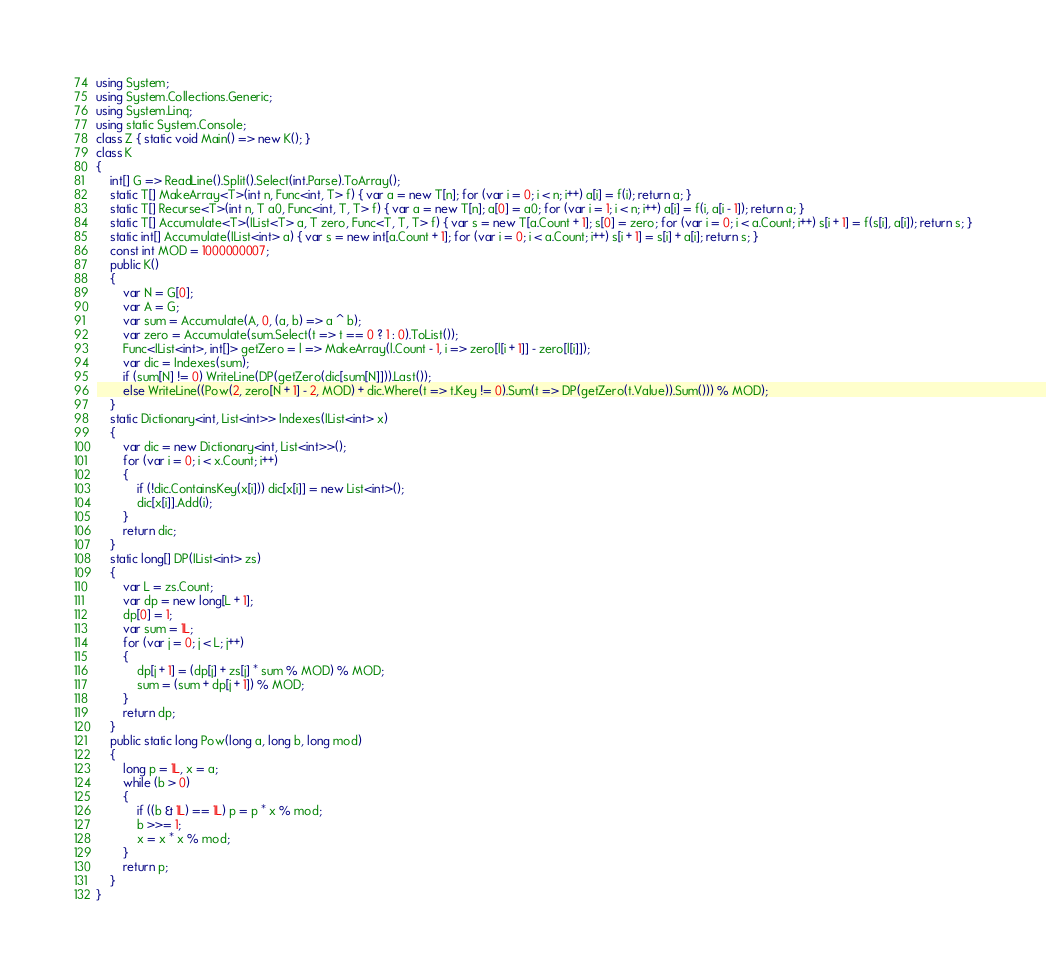<code> <loc_0><loc_0><loc_500><loc_500><_C#_>using System;
using System.Collections.Generic;
using System.Linq;
using static System.Console;
class Z { static void Main() => new K(); }
class K
{
	int[] G => ReadLine().Split().Select(int.Parse).ToArray();
	static T[] MakeArray<T>(int n, Func<int, T> f) { var a = new T[n]; for (var i = 0; i < n; i++) a[i] = f(i); return a; }
	static T[] Recurse<T>(int n, T a0, Func<int, T, T> f) { var a = new T[n]; a[0] = a0; for (var i = 1; i < n; i++) a[i] = f(i, a[i - 1]); return a; }
	static T[] Accumulate<T>(IList<T> a, T zero, Func<T, T, T> f) { var s = new T[a.Count + 1]; s[0] = zero; for (var i = 0; i < a.Count; i++) s[i + 1] = f(s[i], a[i]); return s; }
	static int[] Accumulate(IList<int> a) { var s = new int[a.Count + 1]; for (var i = 0; i < a.Count; i++) s[i + 1] = s[i] + a[i]; return s; }
	const int MOD = 1000000007;
	public K()
	{
		var N = G[0];
		var A = G;
		var sum = Accumulate(A, 0, (a, b) => a ^ b);
		var zero = Accumulate(sum.Select(t => t == 0 ? 1 : 0).ToList());
		Func<IList<int>, int[]> getZero = l => MakeArray(l.Count - 1, i => zero[l[i + 1]] - zero[l[i]]);
		var dic = Indexes(sum);
		if (sum[N] != 0) WriteLine(DP(getZero(dic[sum[N]])).Last());
		else WriteLine((Pow(2, zero[N + 1] - 2, MOD) + dic.Where(t => t.Key != 0).Sum(t => DP(getZero(t.Value)).Sum())) % MOD);
	}
	static Dictionary<int, List<int>> Indexes(IList<int> x)
	{
		var dic = new Dictionary<int, List<int>>();
		for (var i = 0; i < x.Count; i++)
		{
			if (!dic.ContainsKey(x[i])) dic[x[i]] = new List<int>();
			dic[x[i]].Add(i);
		}
		return dic;
	}
	static long[] DP(IList<int> zs)
	{
		var L = zs.Count;
		var dp = new long[L + 1];
		dp[0] = 1;
		var sum = 1L;
		for (var j = 0; j < L; j++)
		{
			dp[j + 1] = (dp[j] + zs[j] * sum % MOD) % MOD;
			sum = (sum + dp[j + 1]) % MOD;
		}
		return dp;
	}
	public static long Pow(long a, long b, long mod)
	{
		long p = 1L, x = a;
		while (b > 0)
		{
			if ((b & 1L) == 1L) p = p * x % mod;
			b >>= 1;
			x = x * x % mod;
		}
		return p;
	}
}
</code> 